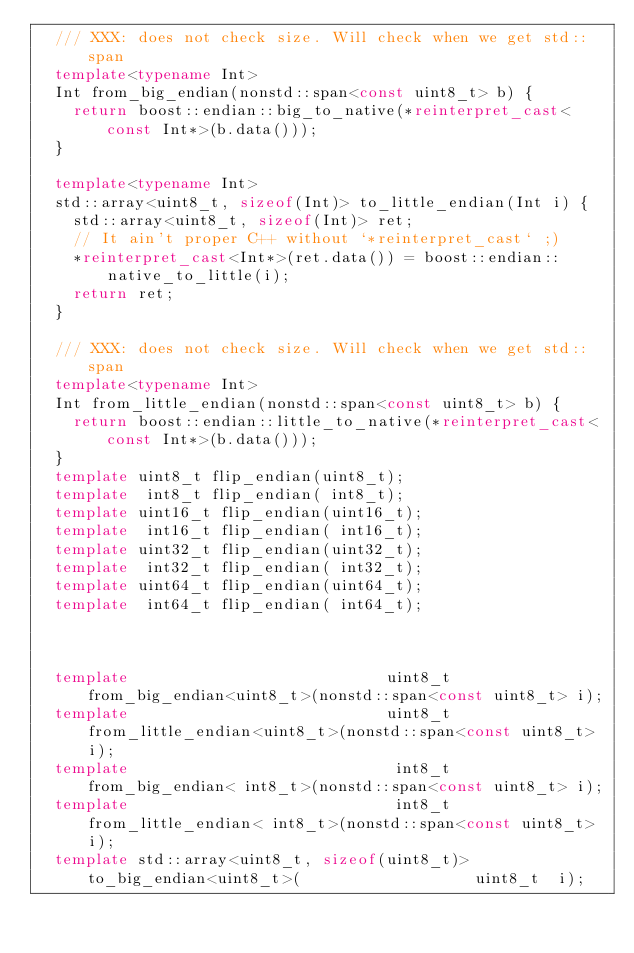<code> <loc_0><loc_0><loc_500><loc_500><_C++_>  /// XXX: does not check size. Will check when we get std::span
  template<typename Int>
  Int from_big_endian(nonstd::span<const uint8_t> b) {
    return boost::endian::big_to_native(*reinterpret_cast<const Int*>(b.data()));
  }

  template<typename Int>
  std::array<uint8_t, sizeof(Int)> to_little_endian(Int i) {
    std::array<uint8_t, sizeof(Int)> ret;
    // It ain't proper C++ without `*reinterpret_cast` ;)
    *reinterpret_cast<Int*>(ret.data()) = boost::endian::native_to_little(i);
    return ret;
  }

  /// XXX: does not check size. Will check when we get std::span
  template<typename Int>
  Int from_little_endian(nonstd::span<const uint8_t> b) {
    return boost::endian::little_to_native(*reinterpret_cast<const Int*>(b.data()));
  }
  template uint8_t flip_endian(uint8_t);
  template  int8_t flip_endian( int8_t);
  template uint16_t flip_endian(uint16_t);
  template  int16_t flip_endian( int16_t);
  template uint32_t flip_endian(uint32_t);
  template  int32_t flip_endian( int32_t);
  template uint64_t flip_endian(uint64_t);
  template  int64_t flip_endian( int64_t);



  template                            uint8_t      from_big_endian<uint8_t>(nonstd::span<const uint8_t> i);
  template                            uint8_t   from_little_endian<uint8_t>(nonstd::span<const uint8_t> i);
  template                             int8_t      from_big_endian< int8_t>(nonstd::span<const uint8_t> i);
  template                             int8_t   from_little_endian< int8_t>(nonstd::span<const uint8_t> i);
  template std::array<uint8_t, sizeof(uint8_t)>      to_big_endian<uint8_t>(                   uint8_t  i);</code> 